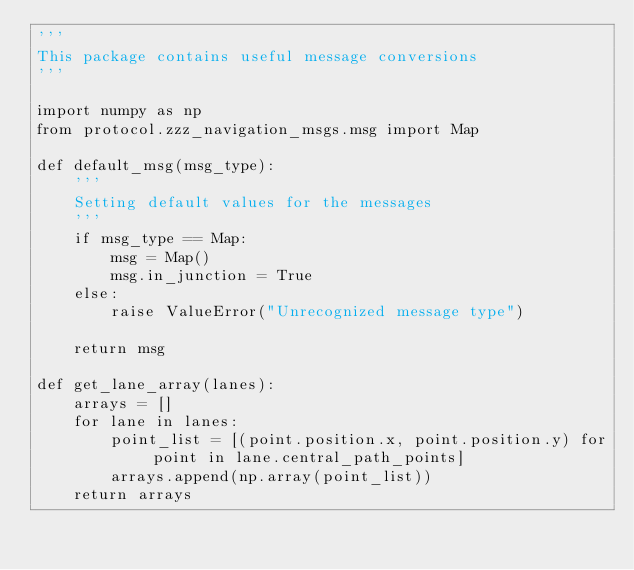Convert code to text. <code><loc_0><loc_0><loc_500><loc_500><_Python_>'''
This package contains useful message conversions
'''

import numpy as np
from protocol.zzz_navigation_msgs.msg import Map

def default_msg(msg_type):
    '''
    Setting default values for the messages
    '''
    if msg_type == Map:
        msg = Map()
        msg.in_junction = True
    else:
        raise ValueError("Unrecognized message type")
    
    return msg

def get_lane_array(lanes):
    arrays = []
    for lane in lanes:
        point_list = [(point.position.x, point.position.y) for point in lane.central_path_points]
        arrays.append(np.array(point_list))
    return arrays
</code> 